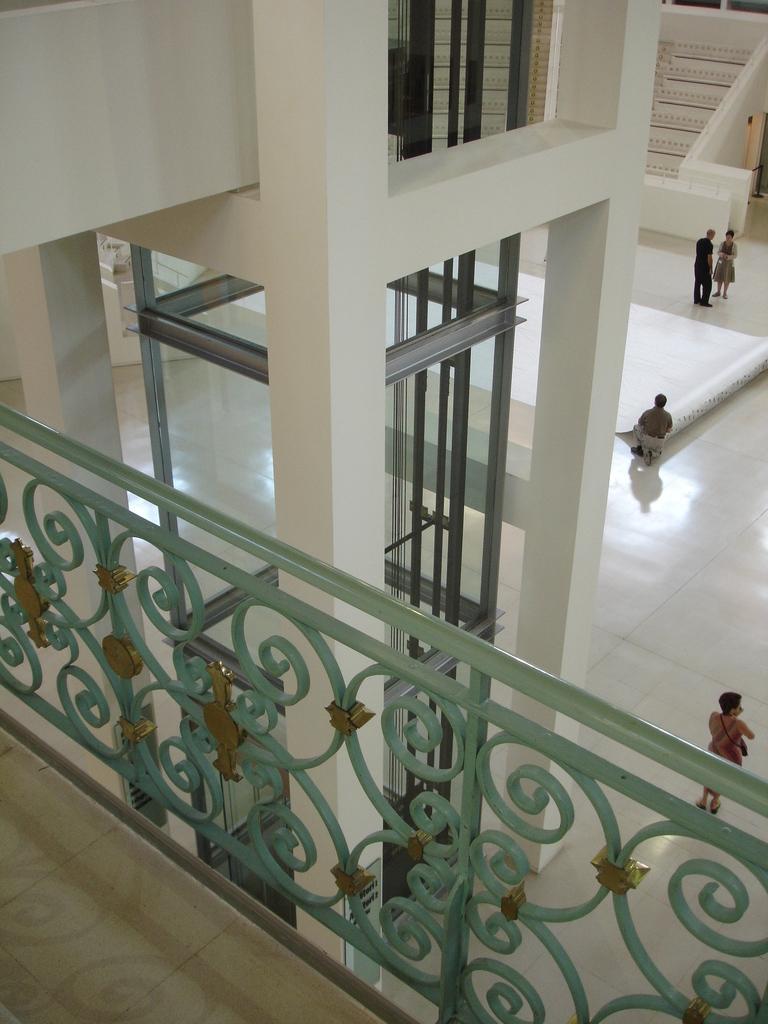How would you summarize this image in a sentence or two? In the picture we can see a view from inside the building and from an upper floor patch and railing and from it we can see deep on the ground floor with white tiles and some people walking on it and in the background we can see the steps and railing to it. 